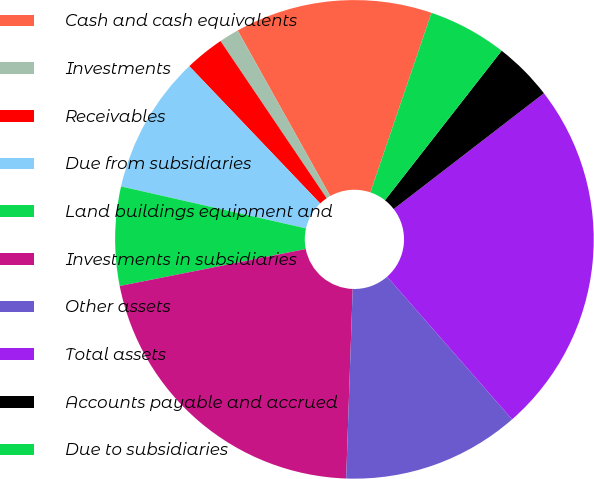Convert chart. <chart><loc_0><loc_0><loc_500><loc_500><pie_chart><fcel>Cash and cash equivalents<fcel>Investments<fcel>Receivables<fcel>Due from subsidiaries<fcel>Land buildings equipment and<fcel>Investments in subsidiaries<fcel>Other assets<fcel>Total assets<fcel>Accounts payable and accrued<fcel>Due to subsidiaries<nl><fcel>13.33%<fcel>1.34%<fcel>2.67%<fcel>9.33%<fcel>6.67%<fcel>21.33%<fcel>12.0%<fcel>24.0%<fcel>4.0%<fcel>5.33%<nl></chart> 